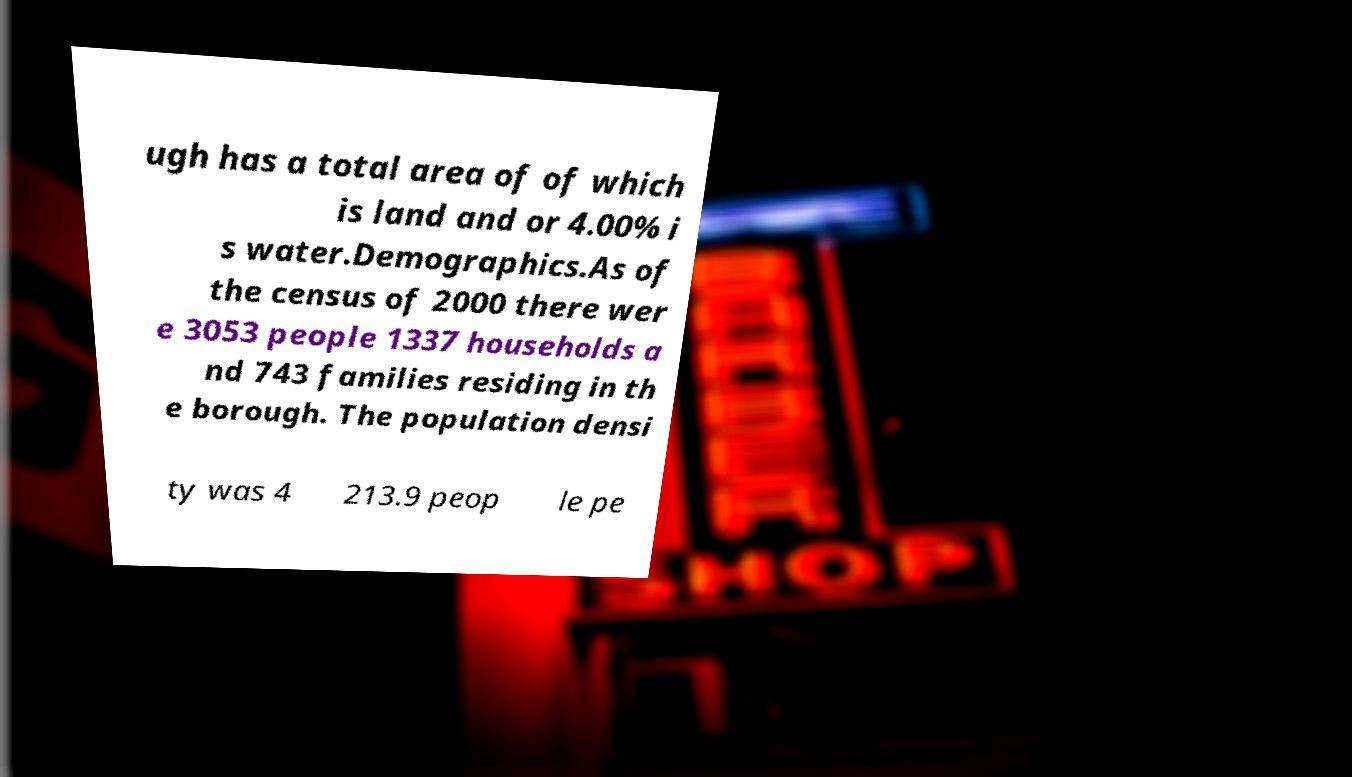Please identify and transcribe the text found in this image. ugh has a total area of of which is land and or 4.00% i s water.Demographics.As of the census of 2000 there wer e 3053 people 1337 households a nd 743 families residing in th e borough. The population densi ty was 4 213.9 peop le pe 